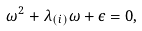<formula> <loc_0><loc_0><loc_500><loc_500>\omega ^ { 2 } + \lambda _ { ( i ) } \omega + \epsilon = 0 ,</formula> 